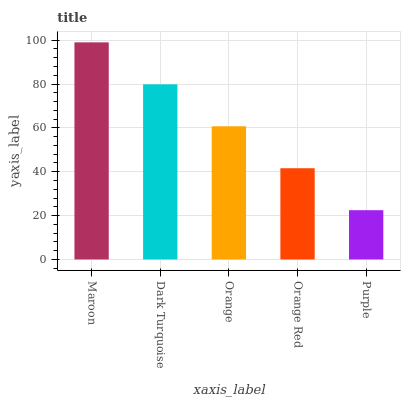Is Dark Turquoise the minimum?
Answer yes or no. No. Is Dark Turquoise the maximum?
Answer yes or no. No. Is Maroon greater than Dark Turquoise?
Answer yes or no. Yes. Is Dark Turquoise less than Maroon?
Answer yes or no. Yes. Is Dark Turquoise greater than Maroon?
Answer yes or no. No. Is Maroon less than Dark Turquoise?
Answer yes or no. No. Is Orange the high median?
Answer yes or no. Yes. Is Orange the low median?
Answer yes or no. Yes. Is Orange Red the high median?
Answer yes or no. No. Is Orange Red the low median?
Answer yes or no. No. 